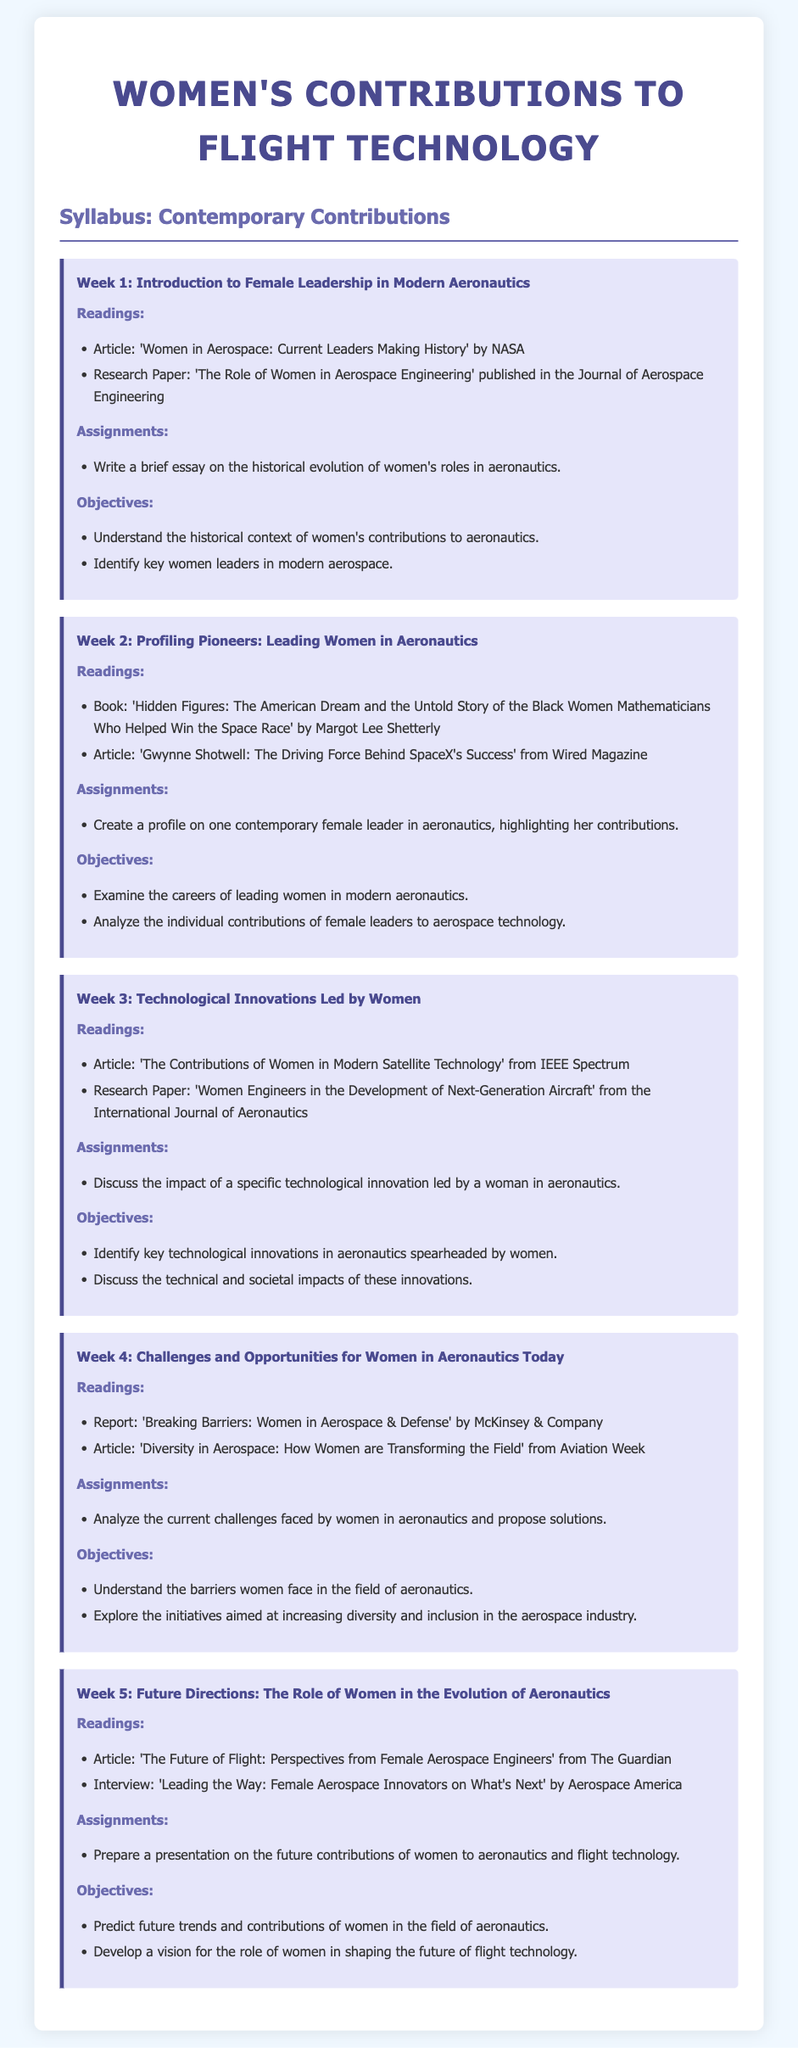What is the title of the syllabus? The title of the syllabus is indicated at the top of the document, which describes its focus on women's contributions to flight technology.
Answer: Women's Contributions to Flight Technology What is the first week's focus? The first week focuses on introducing female leadership in modern aeronautics, as stated in the week title.
Answer: Introduction to Female Leadership in Modern Aeronautics Who authored the article titled 'Women in Aerospace: Current Leaders Making History'? The author of the specified article is NASA, which is mentioned in the readings section of Week 1.
Answer: NASA What is the objective for Week 2? The second week's objectives include analyzing the individual contributions of female leaders to aerospace technology.
Answer: Analyze the individual contributions of female leaders to aerospace technology What is a reading for Week 4? The readings for the fourth week include a report by McKinsey & Company on women in aerospace and defense.
Answer: Breaking Barriers: Women in Aerospace & Defense What type of project is assigned in Week 5? The assignment for the fifth week involves preparing a presentation on future contributions of women to aeronautics.
Answer: Prepare a presentation on the future contributions of women to aeronautics What significant work is referenced in Week 2? A significant work referenced in the second week is a book that details the contributions of black women mathematicians in the context of the space race.
Answer: Hidden Figures: The American Dream and the Untold Story of the Black Women Mathematicians Who Helped Win the Space Race What was discussed in Week 3 regarding women's contributions? The discussion in the third week focuses on identifying technological innovations in aeronautics that were led by women.
Answer: Identify key technological innovations in aeronautics spearheaded by women How many weeks are included in the syllabus? The syllabus consists of five distinct weekly topics throughout the document.
Answer: 5 